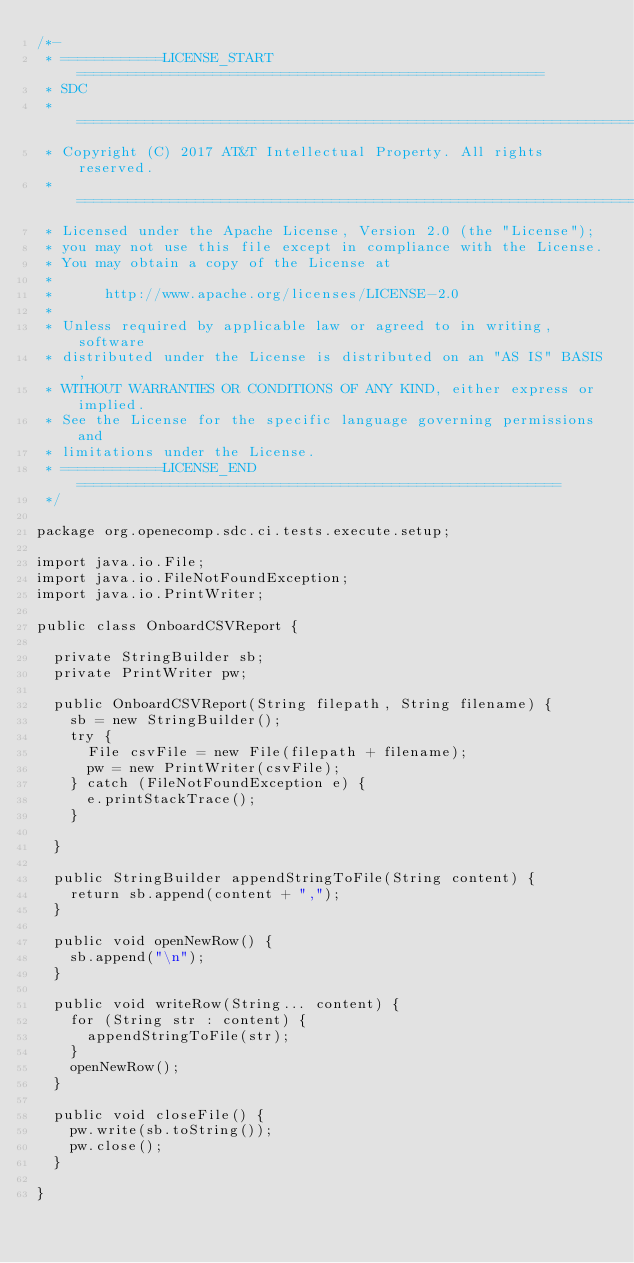<code> <loc_0><loc_0><loc_500><loc_500><_Java_>/*-
 * ============LICENSE_START=======================================================
 * SDC
 * ================================================================================
 * Copyright (C) 2017 AT&T Intellectual Property. All rights reserved.
 * ================================================================================
 * Licensed under the Apache License, Version 2.0 (the "License");
 * you may not use this file except in compliance with the License.
 * You may obtain a copy of the License at
 * 
 *      http://www.apache.org/licenses/LICENSE-2.0
 * 
 * Unless required by applicable law or agreed to in writing, software
 * distributed under the License is distributed on an "AS IS" BASIS,
 * WITHOUT WARRANTIES OR CONDITIONS OF ANY KIND, either express or implied.
 * See the License for the specific language governing permissions and
 * limitations under the License.
 * ============LICENSE_END=========================================================
 */

package org.openecomp.sdc.ci.tests.execute.setup;

import java.io.File;
import java.io.FileNotFoundException;
import java.io.PrintWriter;

public class OnboardCSVReport {

	private StringBuilder sb;
	private PrintWriter pw;

	public OnboardCSVReport(String filepath, String filename) {
		sb = new StringBuilder();
		try {
			File csvFile = new File(filepath + filename);
			pw = new PrintWriter(csvFile);
		} catch (FileNotFoundException e) {
			e.printStackTrace();
		}

	}

	public StringBuilder appendStringToFile(String content) {
		return sb.append(content + ",");
	}

	public void openNewRow() {
		sb.append("\n");
	}

	public void writeRow(String... content) {
		for (String str : content) {
			appendStringToFile(str);
		}
		openNewRow();
	}

	public void closeFile() {
		pw.write(sb.toString());
		pw.close();
	}

}
</code> 